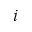<formula> <loc_0><loc_0><loc_500><loc_500>i</formula> 